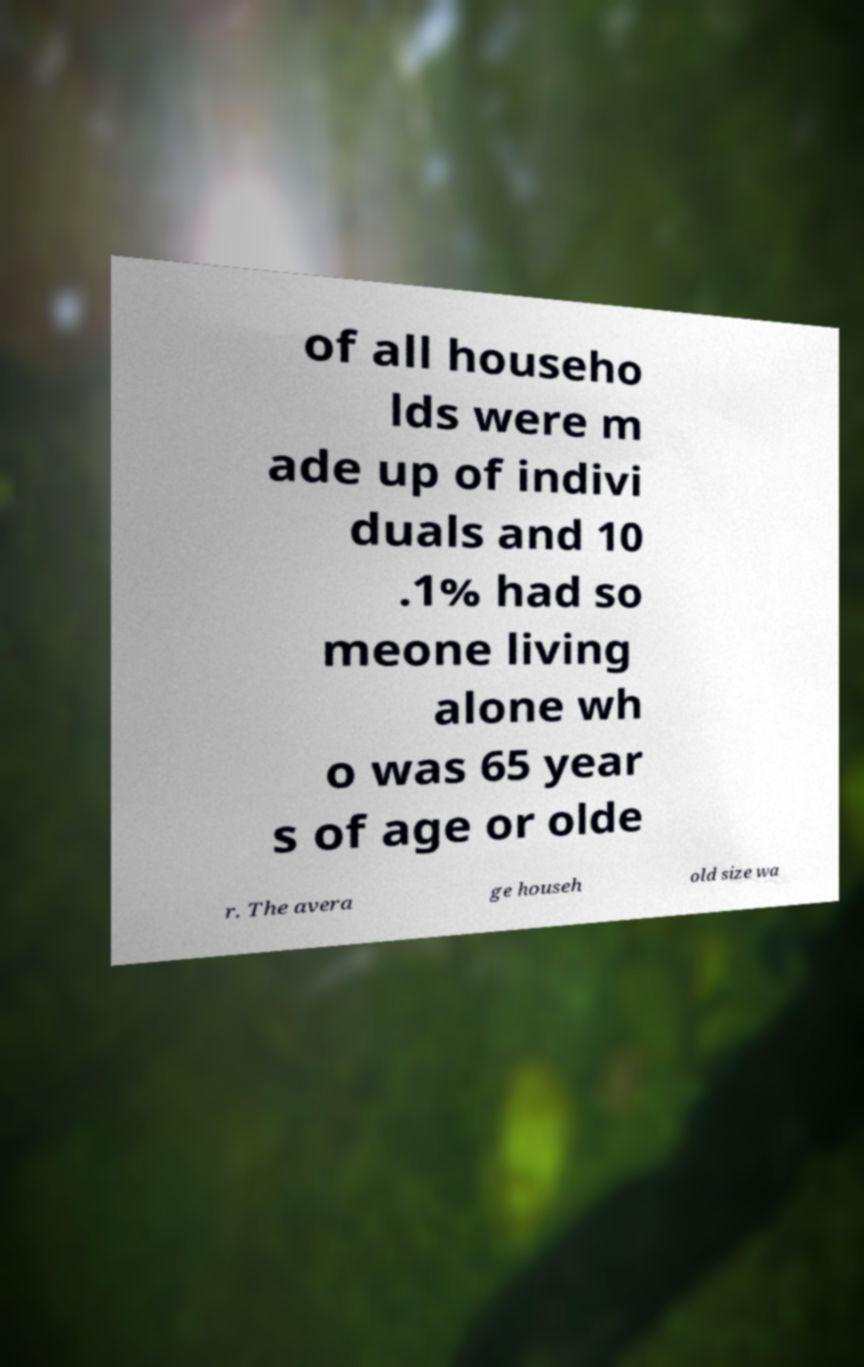There's text embedded in this image that I need extracted. Can you transcribe it verbatim? of all househo lds were m ade up of indivi duals and 10 .1% had so meone living alone wh o was 65 year s of age or olde r. The avera ge househ old size wa 